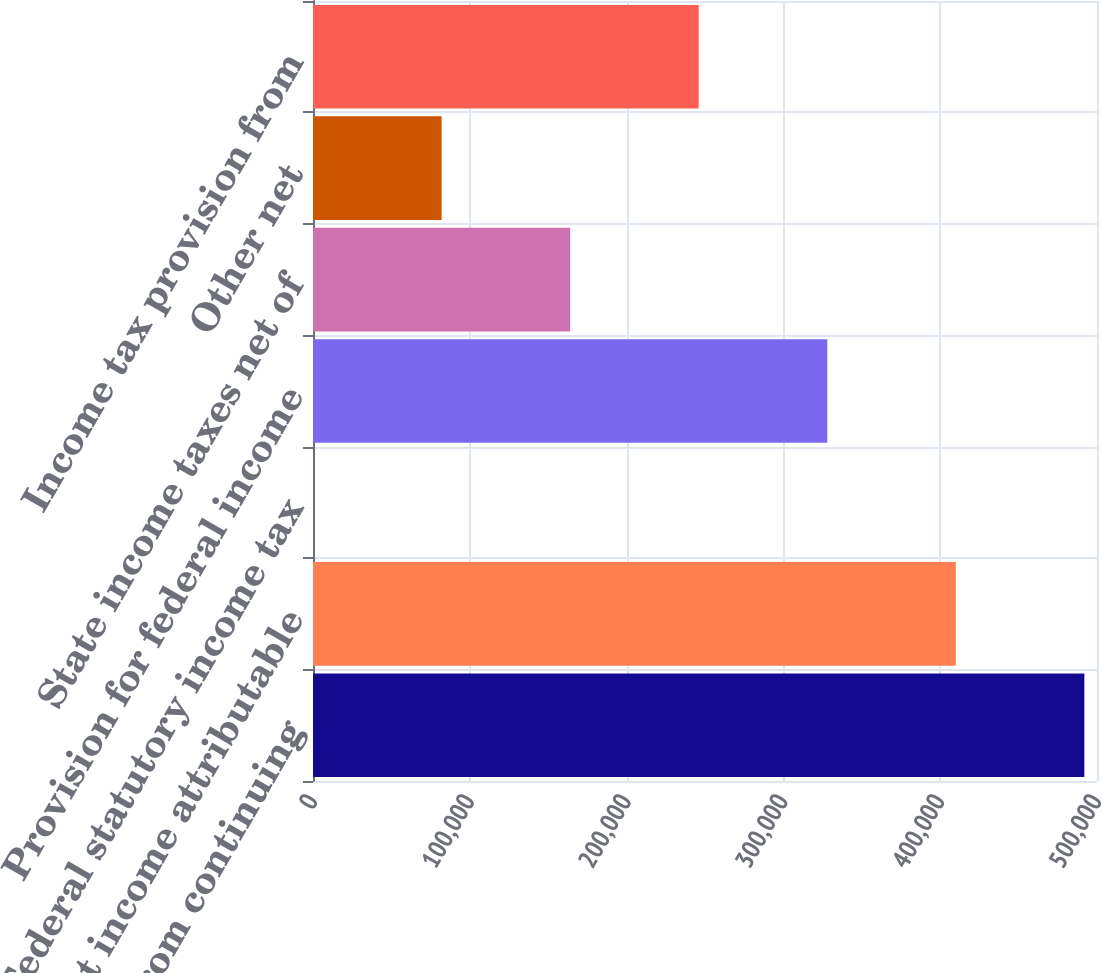Convert chart. <chart><loc_0><loc_0><loc_500><loc_500><bar_chart><fcel>Income from continuing<fcel>Less Net income attributable<fcel>Federal statutory income tax<fcel>Provision for federal income<fcel>State income taxes net of<fcel>Other net<fcel>Income tax provision from<nl><fcel>491938<fcel>409954<fcel>35<fcel>327970<fcel>164003<fcel>82018.8<fcel>245986<nl></chart> 